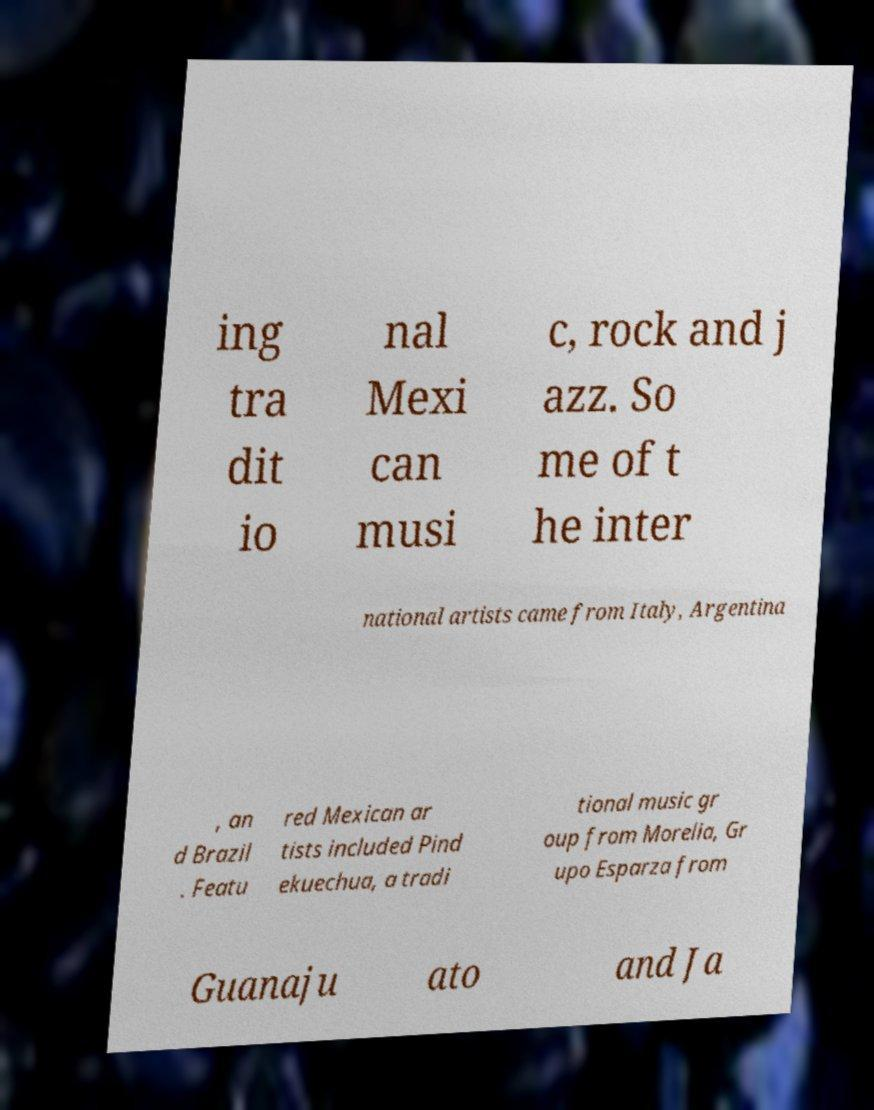Can you read and provide the text displayed in the image?This photo seems to have some interesting text. Can you extract and type it out for me? ing tra dit io nal Mexi can musi c, rock and j azz. So me of t he inter national artists came from Italy, Argentina , an d Brazil . Featu red Mexican ar tists included Pind ekuechua, a tradi tional music gr oup from Morelia, Gr upo Esparza from Guanaju ato and Ja 